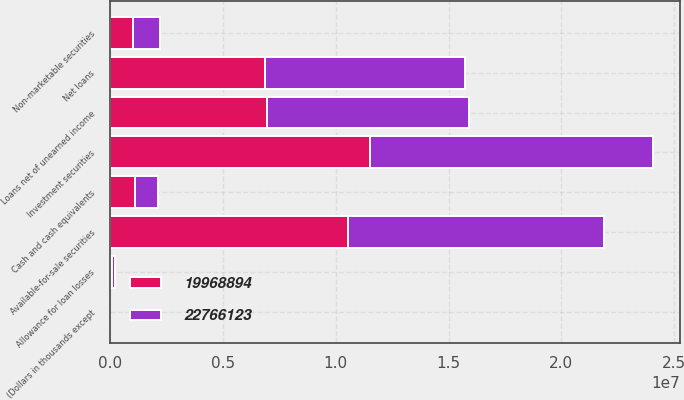Convert chart. <chart><loc_0><loc_0><loc_500><loc_500><stacked_bar_chart><ecel><fcel>(Dollars in thousands except<fcel>Cash and cash equivalents<fcel>Available-for-sale securities<fcel>Non-marketable securities<fcel>Investment securities<fcel>Loans net of unearned income<fcel>Allowance for loan losses<fcel>Net loans<nl><fcel>2.27661e+07<fcel>2012<fcel>1.00898e+06<fcel>1.13432e+07<fcel>1.18426e+06<fcel>1.25274e+07<fcel>8.94693e+06<fcel>110651<fcel>8.83628e+06<nl><fcel>1.99689e+07<fcel>2011<fcel>1.11495e+06<fcel>1.0536e+07<fcel>1.00444e+06<fcel>1.15405e+07<fcel>6.97008e+06<fcel>89947<fcel>6.88014e+06<nl></chart> 